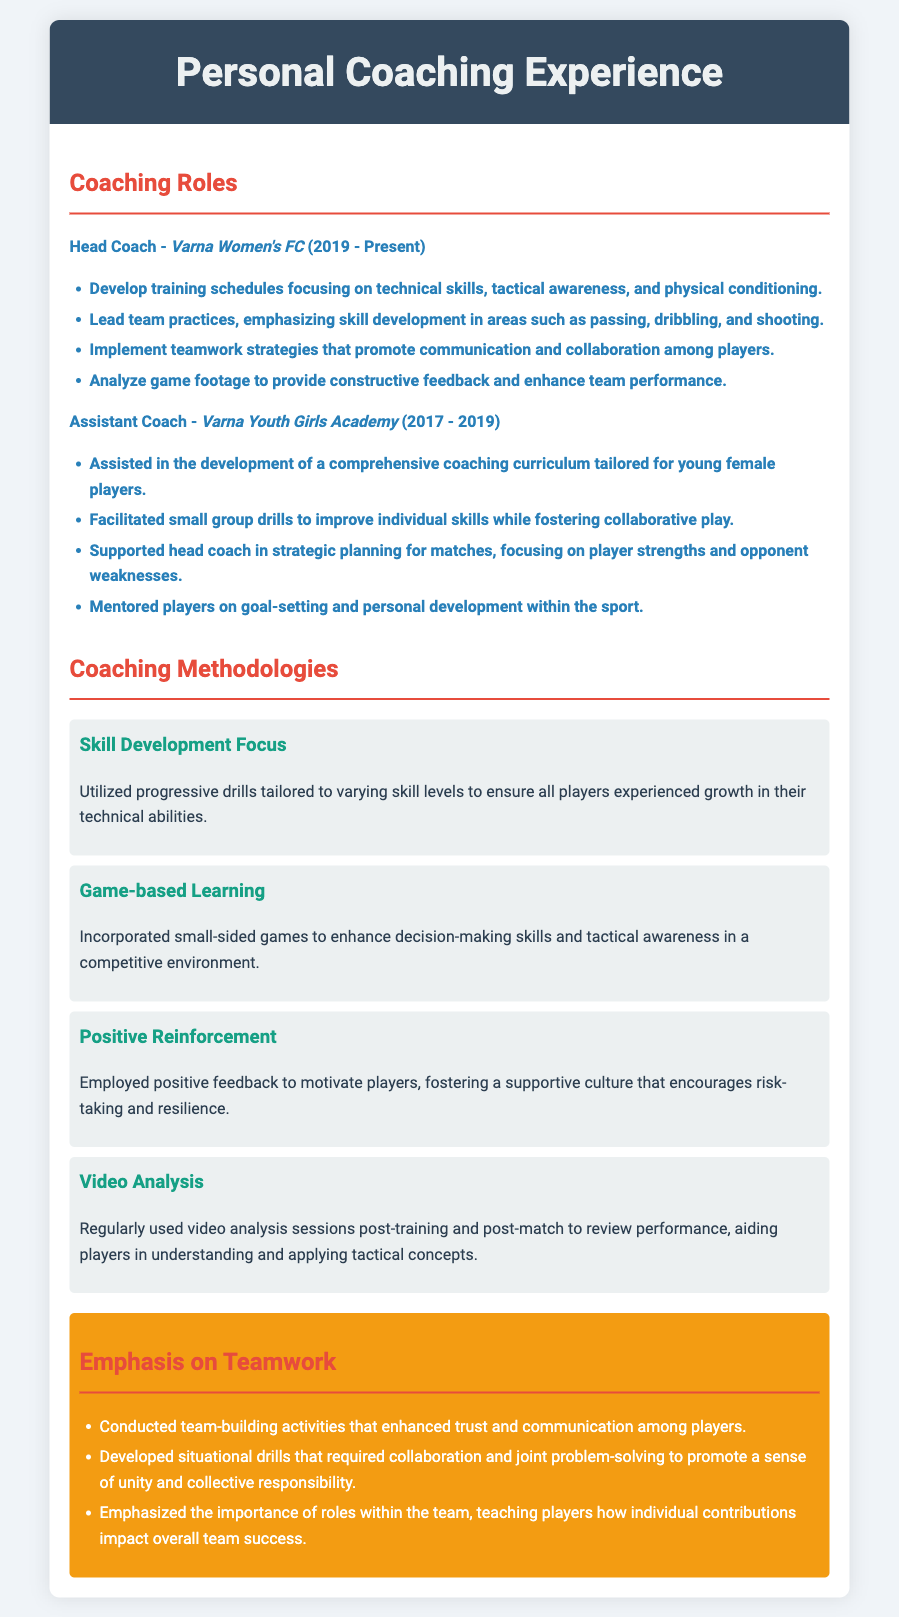what is the current role of the coach? The resume states the individual is the Head Coach at Varna Women's FC.
Answer: Head Coach what is the name of the team coached from 2017 to 2019? The resume mentions the individual was an Assistant Coach at Varna Youth Girls Academy during that time.
Answer: Varna Youth Girls Academy how many methodologies are listed in the document? The document outlines four distinct coaching methodologies.
Answer: Four which methodology involves using video sessions? The document describes Video Analysis as a methodology that uses video sessions.
Answer: Video Analysis what type of activities were conducted to enhance trust among players? Team-building activities specifically aimed at improving trust and communication were conducted.
Answer: Team-building activities what is emphasized alongside skill development in coaching? The document emphasizes teamwork strategies alongside skill development.
Answer: Teamwork what year did the coaching role at Varna Women's FC begin? According to the document, the coaching role started in 2019.
Answer: 2019 which skill area was emphasized in training schedules? The resume highlights technical skills in the training schedules developed by the coach.
Answer: Technical skills 